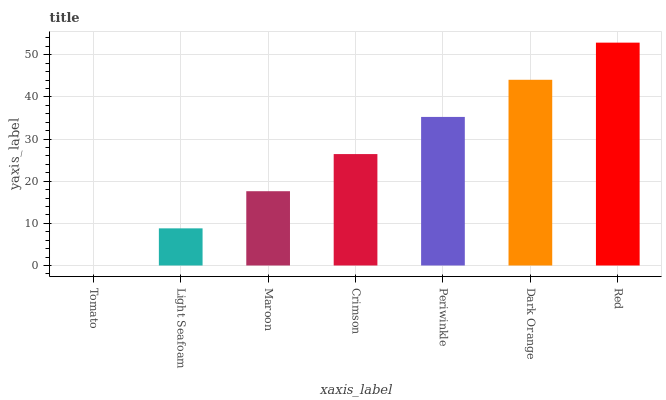Is Tomato the minimum?
Answer yes or no. Yes. Is Red the maximum?
Answer yes or no. Yes. Is Light Seafoam the minimum?
Answer yes or no. No. Is Light Seafoam the maximum?
Answer yes or no. No. Is Light Seafoam greater than Tomato?
Answer yes or no. Yes. Is Tomato less than Light Seafoam?
Answer yes or no. Yes. Is Tomato greater than Light Seafoam?
Answer yes or no. No. Is Light Seafoam less than Tomato?
Answer yes or no. No. Is Crimson the high median?
Answer yes or no. Yes. Is Crimson the low median?
Answer yes or no. Yes. Is Red the high median?
Answer yes or no. No. Is Dark Orange the low median?
Answer yes or no. No. 